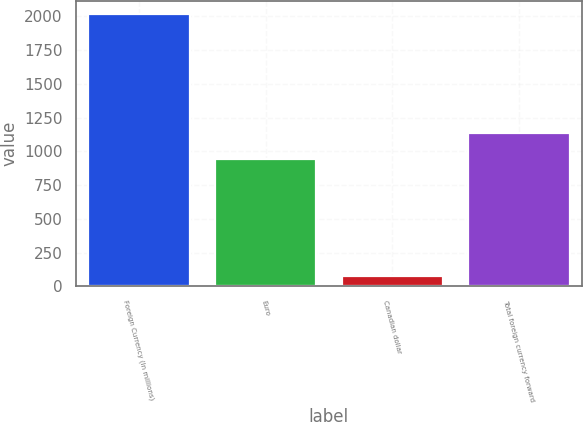<chart> <loc_0><loc_0><loc_500><loc_500><bar_chart><fcel>Foreign Currency (In millions)<fcel>Euro<fcel>Canadian dollar<fcel>Total foreign currency forward<nl><fcel>2015<fcel>945.5<fcel>76.7<fcel>1139.33<nl></chart> 